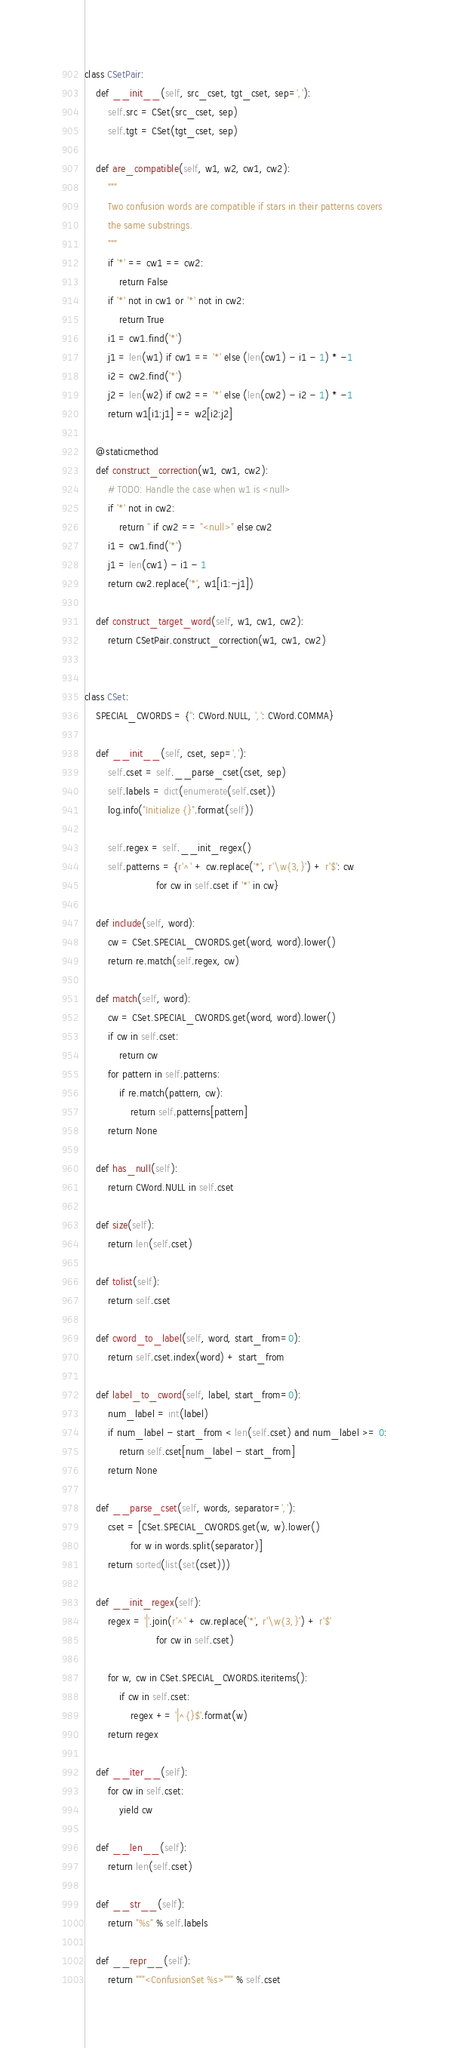Convert code to text. <code><loc_0><loc_0><loc_500><loc_500><_Python_>
class CSetPair:
    def __init__(self, src_cset, tgt_cset, sep=','):
        self.src = CSet(src_cset, sep)
        self.tgt = CSet(tgt_cset, sep)

    def are_compatible(self, w1, w2, cw1, cw2):
        """
        Two confusion words are compatible if stars in their patterns covers
        the same substrings.
        """
        if '*' == cw1 == cw2:
            return False
        if '*' not in cw1 or '*' not in cw2:
            return True
        i1 = cw1.find('*')
        j1 = len(w1) if cw1 == '*' else (len(cw1) - i1 - 1) * -1
        i2 = cw2.find('*')
        j2 = len(w2) if cw2 == '*' else (len(cw2) - i2 - 1) * -1
        return w1[i1:j1] == w2[i2:j2]

    @staticmethod
    def construct_correction(w1, cw1, cw2):
        # TODO: Handle the case when w1 is <null>
        if '*' not in cw2:
            return '' if cw2 == "<null>" else cw2
        i1 = cw1.find('*')
        j1 = len(cw1) - i1 - 1
        return cw2.replace('*', w1[i1:-j1])

    def construct_target_word(self, w1, cw1, cw2):
        return CSetPair.construct_correction(w1, cw1, cw2)


class CSet:
    SPECIAL_CWORDS = {'': CWord.NULL, ',': CWord.COMMA}

    def __init__(self, cset, sep=','):
        self.cset = self.__parse_cset(cset, sep)
        self.labels = dict(enumerate(self.cset))
        log.info("Initialize {}".format(self))

        self.regex = self.__init_regex()
        self.patterns = {r'^' + cw.replace('*', r'\w{3,}') + r'$': cw
                         for cw in self.cset if '*' in cw}

    def include(self, word):
        cw = CSet.SPECIAL_CWORDS.get(word, word).lower()
        return re.match(self.regex, cw)

    def match(self, word):
        cw = CSet.SPECIAL_CWORDS.get(word, word).lower()
        if cw in self.cset:
            return cw
        for pattern in self.patterns:
            if re.match(pattern, cw):
                return self.patterns[pattern]
        return None

    def has_null(self):
        return CWord.NULL in self.cset

    def size(self):
        return len(self.cset)

    def tolist(self):
        return self.cset

    def cword_to_label(self, word, start_from=0):
        return self.cset.index(word) + start_from

    def label_to_cword(self, label, start_from=0):
        num_label = int(label)
        if num_label - start_from < len(self.cset) and num_label >= 0:
            return self.cset[num_label - start_from]
        return None

    def __parse_cset(self, words, separator=','):
        cset = [CSet.SPECIAL_CWORDS.get(w, w).lower()
                for w in words.split(separator)]
        return sorted(list(set(cset)))

    def __init_regex(self):
        regex = '|'.join(r'^' + cw.replace('*', r'\w{3,}') + r'$'
                         for cw in self.cset)

        for w, cw in CSet.SPECIAL_CWORDS.iteritems():
            if cw in self.cset:
                regex += '|^{}$'.format(w)
        return regex

    def __iter__(self):
        for cw in self.cset:
            yield cw

    def __len__(self):
        return len(self.cset)

    def __str__(self):
        return "%s" % self.labels

    def __repr__(self):
        return """<ConfusionSet %s>""" % self.cset
</code> 